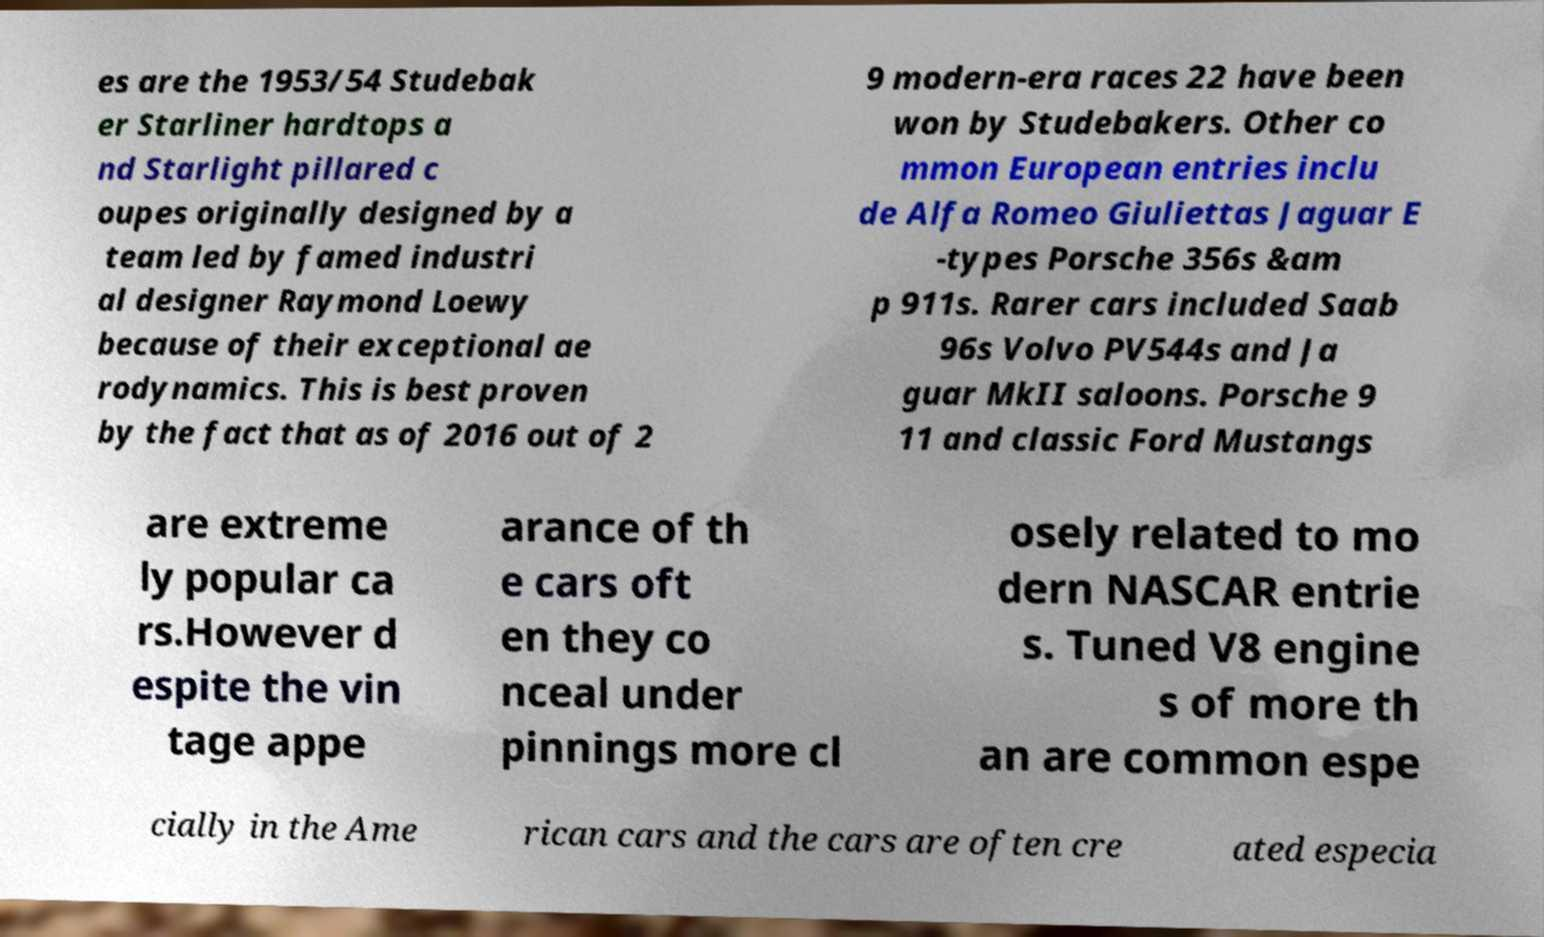Could you extract and type out the text from this image? es are the 1953/54 Studebak er Starliner hardtops a nd Starlight pillared c oupes originally designed by a team led by famed industri al designer Raymond Loewy because of their exceptional ae rodynamics. This is best proven by the fact that as of 2016 out of 2 9 modern-era races 22 have been won by Studebakers. Other co mmon European entries inclu de Alfa Romeo Giuliettas Jaguar E -types Porsche 356s &am p 911s. Rarer cars included Saab 96s Volvo PV544s and Ja guar MkII saloons. Porsche 9 11 and classic Ford Mustangs are extreme ly popular ca rs.However d espite the vin tage appe arance of th e cars oft en they co nceal under pinnings more cl osely related to mo dern NASCAR entrie s. Tuned V8 engine s of more th an are common espe cially in the Ame rican cars and the cars are often cre ated especia 